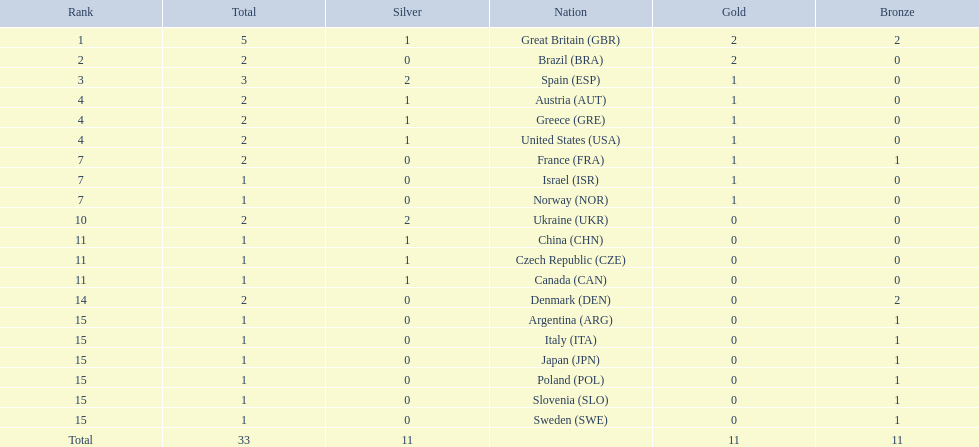What was the number of silver medals won by ukraine? 2. Parse the table in full. {'header': ['Rank', 'Total', 'Silver', 'Nation', 'Gold', 'Bronze'], 'rows': [['1', '5', '1', 'Great Britain\xa0(GBR)', '2', '2'], ['2', '2', '0', 'Brazil\xa0(BRA)', '2', '0'], ['3', '3', '2', 'Spain\xa0(ESP)', '1', '0'], ['4', '2', '1', 'Austria\xa0(AUT)', '1', '0'], ['4', '2', '1', 'Greece\xa0(GRE)', '1', '0'], ['4', '2', '1', 'United States\xa0(USA)', '1', '0'], ['7', '2', '0', 'France\xa0(FRA)', '1', '1'], ['7', '1', '0', 'Israel\xa0(ISR)', '1', '0'], ['7', '1', '0', 'Norway\xa0(NOR)', '1', '0'], ['10', '2', '2', 'Ukraine\xa0(UKR)', '0', '0'], ['11', '1', '1', 'China\xa0(CHN)', '0', '0'], ['11', '1', '1', 'Czech Republic\xa0(CZE)', '0', '0'], ['11', '1', '1', 'Canada\xa0(CAN)', '0', '0'], ['14', '2', '0', 'Denmark\xa0(DEN)', '0', '2'], ['15', '1', '0', 'Argentina\xa0(ARG)', '0', '1'], ['15', '1', '0', 'Italy\xa0(ITA)', '0', '1'], ['15', '1', '0', 'Japan\xa0(JPN)', '0', '1'], ['15', '1', '0', 'Poland\xa0(POL)', '0', '1'], ['15', '1', '0', 'Slovenia\xa0(SLO)', '0', '1'], ['15', '1', '0', 'Sweden\xa0(SWE)', '0', '1'], ['Total', '33', '11', '', '11', '11']]} 